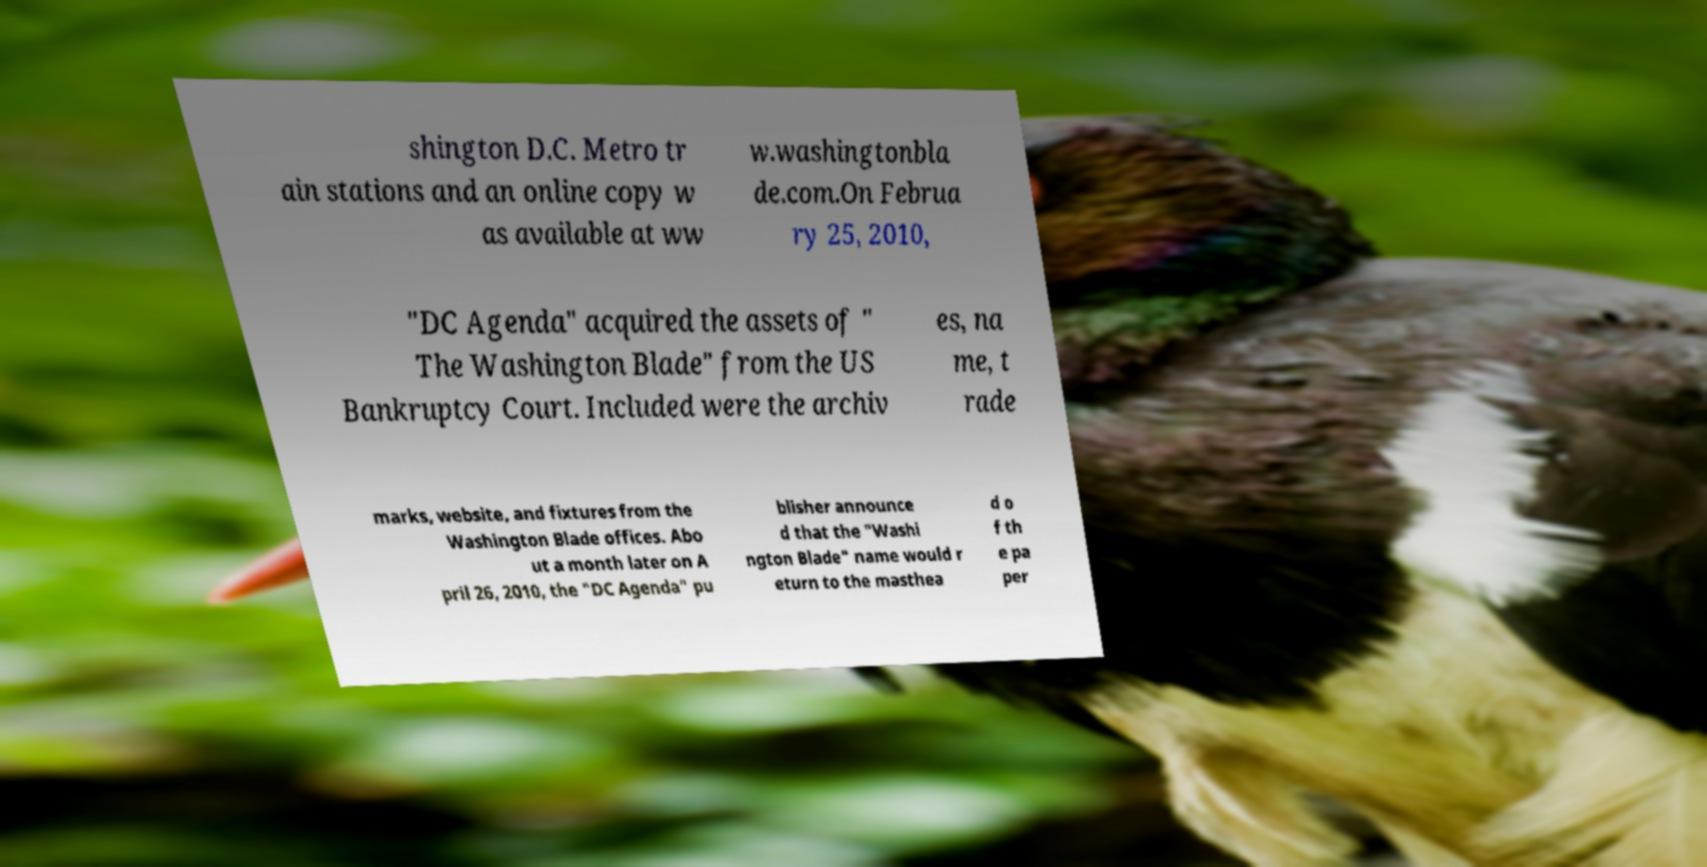I need the written content from this picture converted into text. Can you do that? shington D.C. Metro tr ain stations and an online copy w as available at ww w.washingtonbla de.com.On Februa ry 25, 2010, "DC Agenda" acquired the assets of " The Washington Blade" from the US Bankruptcy Court. Included were the archiv es, na me, t rade marks, website, and fixtures from the Washington Blade offices. Abo ut a month later on A pril 26, 2010, the "DC Agenda" pu blisher announce d that the "Washi ngton Blade" name would r eturn to the masthea d o f th e pa per 